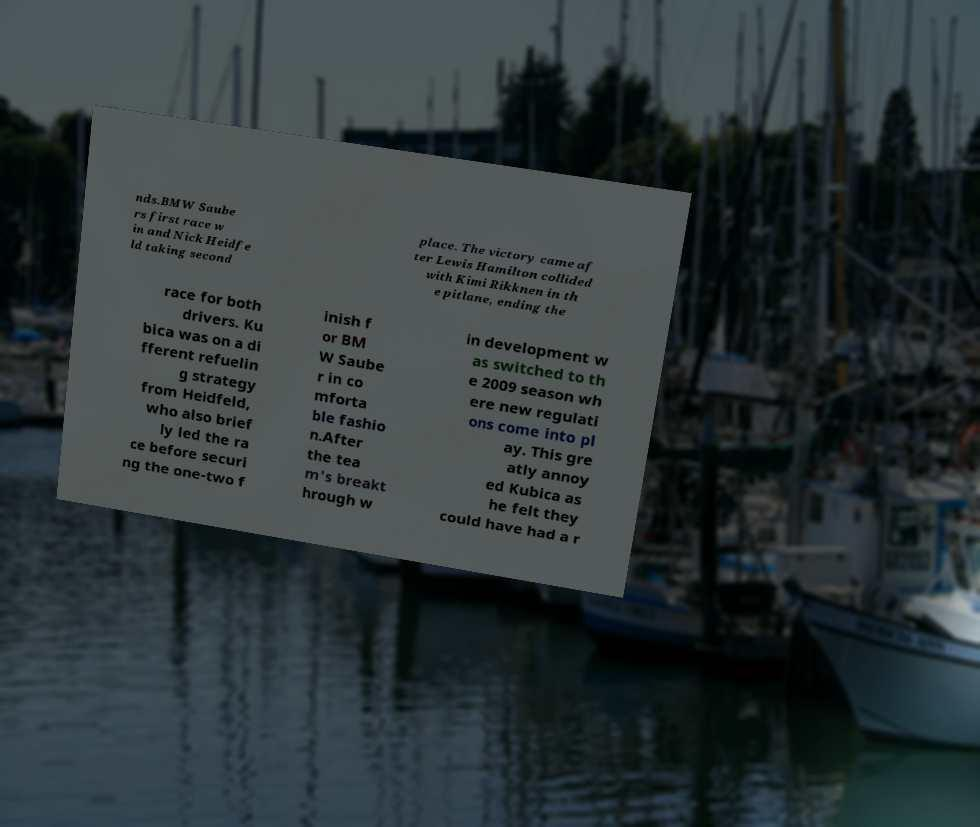Please read and relay the text visible in this image. What does it say? nds.BMW Saube rs first race w in and Nick Heidfe ld taking second place. The victory came af ter Lewis Hamilton collided with Kimi Rikknen in th e pitlane, ending the race for both drivers. Ku bica was on a di fferent refuelin g strategy from Heidfeld, who also brief ly led the ra ce before securi ng the one-two f inish f or BM W Saube r in co mforta ble fashio n.After the tea m's breakt hrough w in development w as switched to th e 2009 season wh ere new regulati ons come into pl ay. This gre atly annoy ed Kubica as he felt they could have had a r 